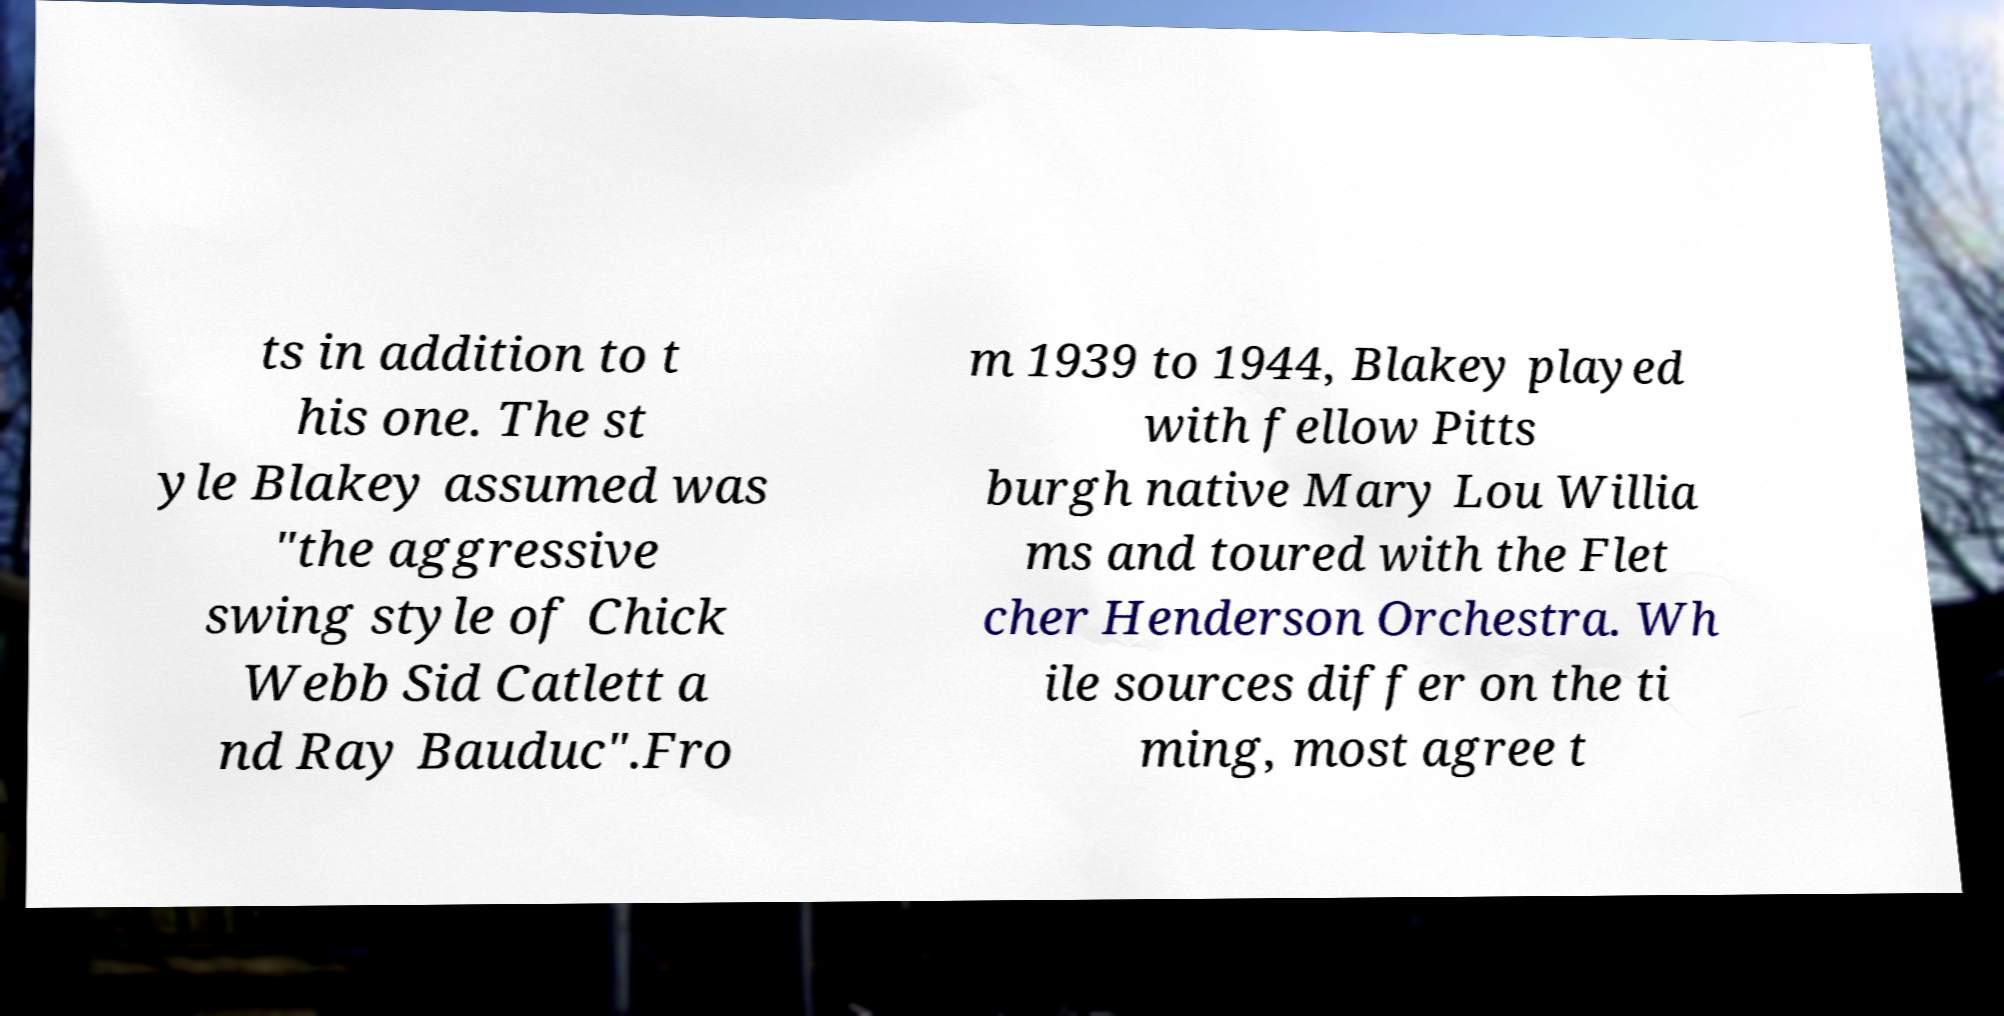Could you extract and type out the text from this image? ts in addition to t his one. The st yle Blakey assumed was "the aggressive swing style of Chick Webb Sid Catlett a nd Ray Bauduc".Fro m 1939 to 1944, Blakey played with fellow Pitts burgh native Mary Lou Willia ms and toured with the Flet cher Henderson Orchestra. Wh ile sources differ on the ti ming, most agree t 